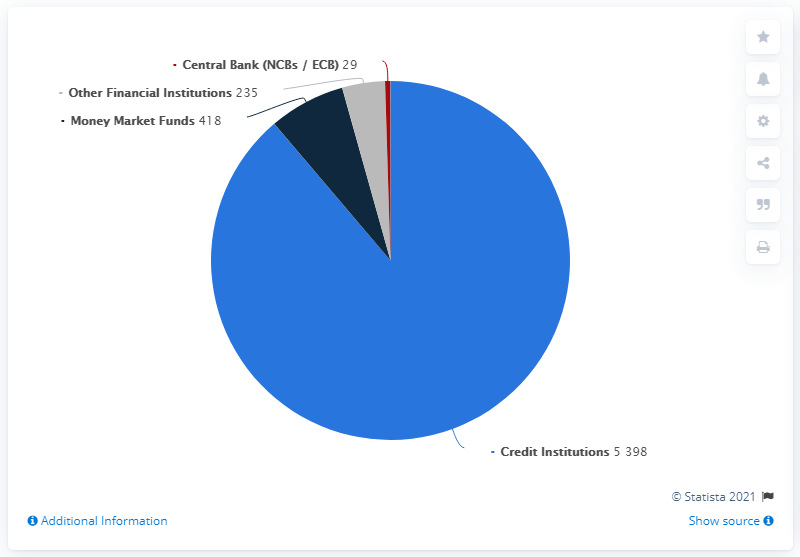Highlight a few significant elements in this photo. It is believed that red has the least value among colors. The difference between the first two highest values is 4980. 